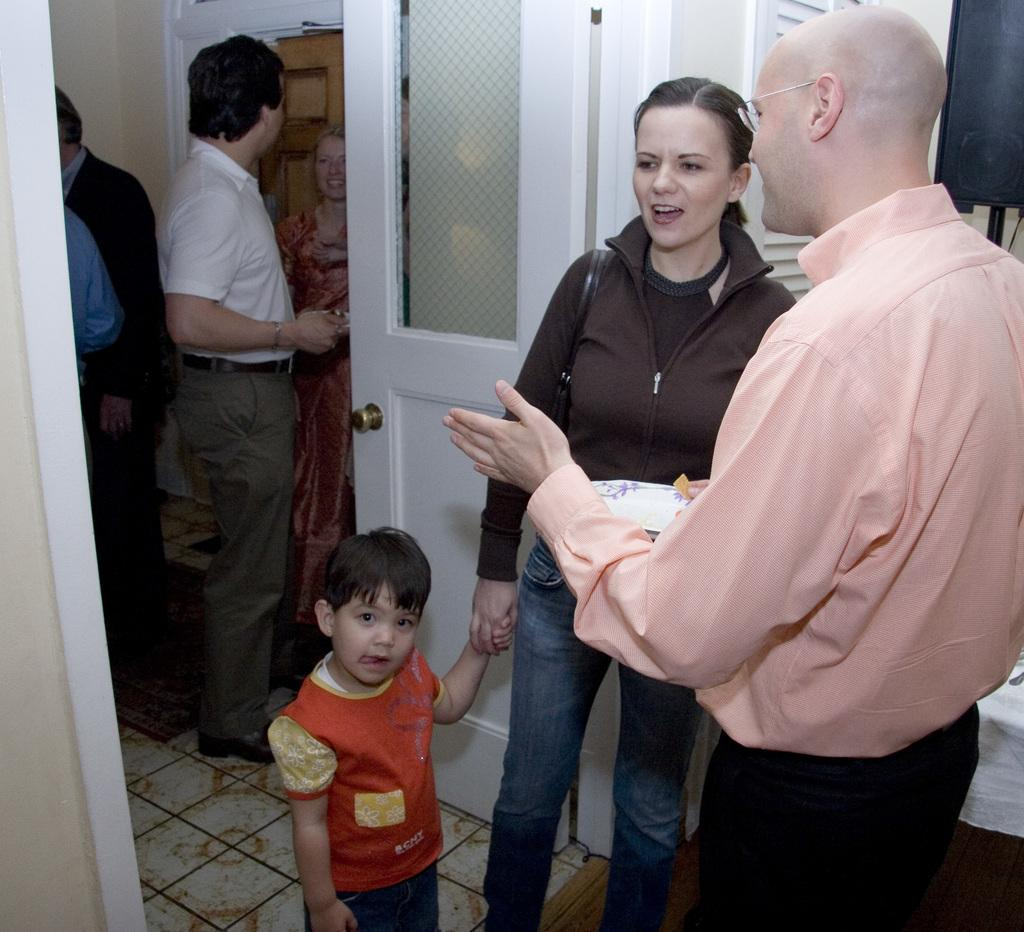How many people are in the image? There is a group of people standing in the image. What is one person holding in the image? One person is holding a plate. What can be seen in the background of the image? There is a door, a television, and a wall visible in the background. What type of lamp is hanging from the ceiling in the image? There is no lamp present in the image. What store can be seen in the background of the image? There is no store visible in the image; only a door, a television, and a wall are present in the background. 